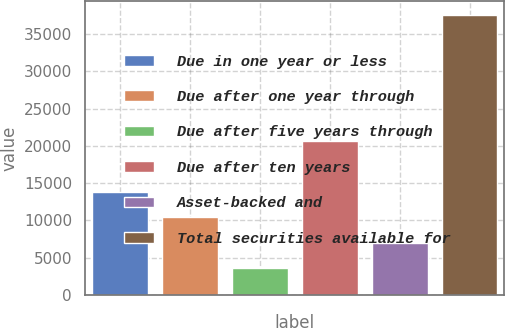<chart> <loc_0><loc_0><loc_500><loc_500><bar_chart><fcel>Due in one year or less<fcel>Due after one year through<fcel>Due after five years through<fcel>Due after ten years<fcel>Asset-backed and<fcel>Total securities available for<nl><fcel>13805.5<fcel>10419<fcel>3646<fcel>20612<fcel>7032.5<fcel>37511<nl></chart> 